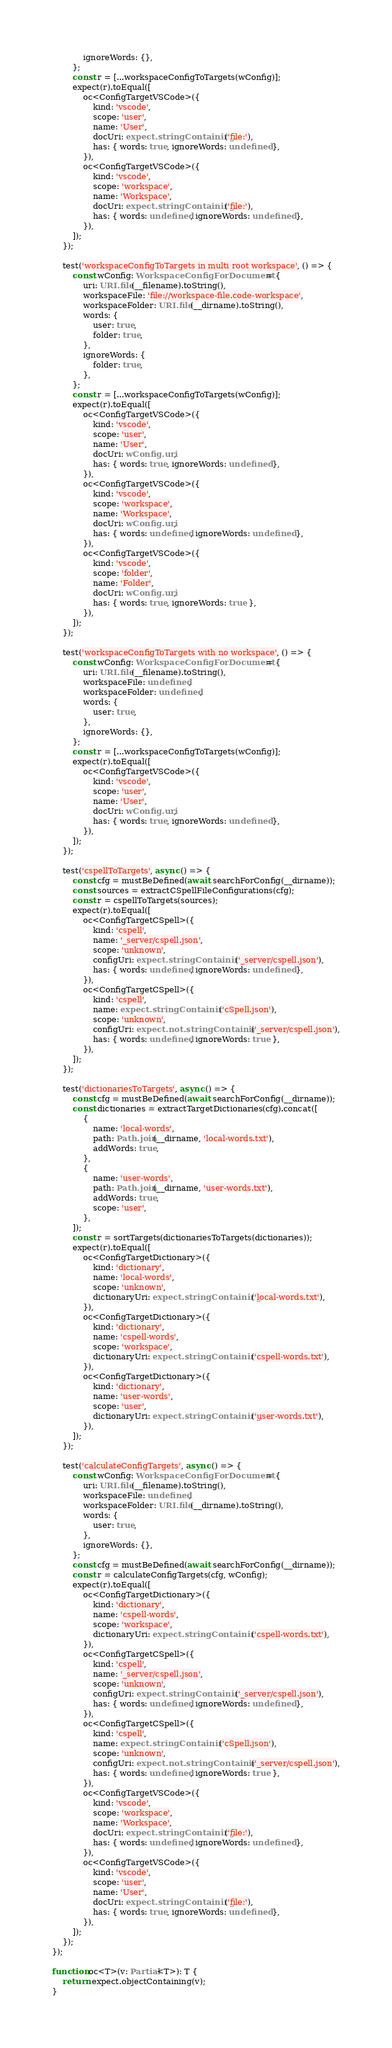Convert code to text. <code><loc_0><loc_0><loc_500><loc_500><_TypeScript_>            ignoreWords: {},
        };
        const r = [...workspaceConfigToTargets(wConfig)];
        expect(r).toEqual([
            oc<ConfigTargetVSCode>({
                kind: 'vscode',
                scope: 'user',
                name: 'User',
                docUri: expect.stringContaining('file:'),
                has: { words: true, ignoreWords: undefined },
            }),
            oc<ConfigTargetVSCode>({
                kind: 'vscode',
                scope: 'workspace',
                name: 'Workspace',
                docUri: expect.stringContaining('file:'),
                has: { words: undefined, ignoreWords: undefined },
            }),
        ]);
    });

    test('workspaceConfigToTargets in multi root workspace', () => {
        const wConfig: WorkspaceConfigForDocument = {
            uri: URI.file(__filename).toString(),
            workspaceFile: 'file://workspace-file.code-workspace',
            workspaceFolder: URI.file(__dirname).toString(),
            words: {
                user: true,
                folder: true,
            },
            ignoreWords: {
                folder: true,
            },
        };
        const r = [...workspaceConfigToTargets(wConfig)];
        expect(r).toEqual([
            oc<ConfigTargetVSCode>({
                kind: 'vscode',
                scope: 'user',
                name: 'User',
                docUri: wConfig.uri,
                has: { words: true, ignoreWords: undefined },
            }),
            oc<ConfigTargetVSCode>({
                kind: 'vscode',
                scope: 'workspace',
                name: 'Workspace',
                docUri: wConfig.uri,
                has: { words: undefined, ignoreWords: undefined },
            }),
            oc<ConfigTargetVSCode>({
                kind: 'vscode',
                scope: 'folder',
                name: 'Folder',
                docUri: wConfig.uri,
                has: { words: true, ignoreWords: true },
            }),
        ]);
    });

    test('workspaceConfigToTargets with no workspace', () => {
        const wConfig: WorkspaceConfigForDocument = {
            uri: URI.file(__filename).toString(),
            workspaceFile: undefined,
            workspaceFolder: undefined,
            words: {
                user: true,
            },
            ignoreWords: {},
        };
        const r = [...workspaceConfigToTargets(wConfig)];
        expect(r).toEqual([
            oc<ConfigTargetVSCode>({
                kind: 'vscode',
                scope: 'user',
                name: 'User',
                docUri: wConfig.uri,
                has: { words: true, ignoreWords: undefined },
            }),
        ]);
    });

    test('cspellToTargets', async () => {
        const cfg = mustBeDefined(await searchForConfig(__dirname));
        const sources = extractCSpellFileConfigurations(cfg);
        const r = cspellToTargets(sources);
        expect(r).toEqual([
            oc<ConfigTargetCSpell>({
                kind: 'cspell',
                name: '_server/cspell.json',
                scope: 'unknown',
                configUri: expect.stringContaining('_server/cspell.json'),
                has: { words: undefined, ignoreWords: undefined },
            }),
            oc<ConfigTargetCSpell>({
                kind: 'cspell',
                name: expect.stringContaining('cSpell.json'),
                scope: 'unknown',
                configUri: expect.not.stringContaining('_server/cspell.json'),
                has: { words: undefined, ignoreWords: true },
            }),
        ]);
    });

    test('dictionariesToTargets', async () => {
        const cfg = mustBeDefined(await searchForConfig(__dirname));
        const dictionaries = extractTargetDictionaries(cfg).concat([
            {
                name: 'local-words',
                path: Path.join(__dirname, 'local-words.txt'),
                addWords: true,
            },
            {
                name: 'user-words',
                path: Path.join(__dirname, 'user-words.txt'),
                addWords: true,
                scope: 'user',
            },
        ]);
        const r = sortTargets(dictionariesToTargets(dictionaries));
        expect(r).toEqual([
            oc<ConfigTargetDictionary>({
                kind: 'dictionary',
                name: 'local-words',
                scope: 'unknown',
                dictionaryUri: expect.stringContaining('local-words.txt'),
            }),
            oc<ConfigTargetDictionary>({
                kind: 'dictionary',
                name: 'cspell-words',
                scope: 'workspace',
                dictionaryUri: expect.stringContaining('cspell-words.txt'),
            }),
            oc<ConfigTargetDictionary>({
                kind: 'dictionary',
                name: 'user-words',
                scope: 'user',
                dictionaryUri: expect.stringContaining('user-words.txt'),
            }),
        ]);
    });

    test('calculateConfigTargets', async () => {
        const wConfig: WorkspaceConfigForDocument = {
            uri: URI.file(__filename).toString(),
            workspaceFile: undefined,
            workspaceFolder: URI.file(__dirname).toString(),
            words: {
                user: true,
            },
            ignoreWords: {},
        };
        const cfg = mustBeDefined(await searchForConfig(__dirname));
        const r = calculateConfigTargets(cfg, wConfig);
        expect(r).toEqual([
            oc<ConfigTargetDictionary>({
                kind: 'dictionary',
                name: 'cspell-words',
                scope: 'workspace',
                dictionaryUri: expect.stringContaining('cspell-words.txt'),
            }),
            oc<ConfigTargetCSpell>({
                kind: 'cspell',
                name: '_server/cspell.json',
                scope: 'unknown',
                configUri: expect.stringContaining('_server/cspell.json'),
                has: { words: undefined, ignoreWords: undefined },
            }),
            oc<ConfigTargetCSpell>({
                kind: 'cspell',
                name: expect.stringContaining('cSpell.json'),
                scope: 'unknown',
                configUri: expect.not.stringContaining('_server/cspell.json'),
                has: { words: undefined, ignoreWords: true },
            }),
            oc<ConfigTargetVSCode>({
                kind: 'vscode',
                scope: 'workspace',
                name: 'Workspace',
                docUri: expect.stringContaining('file:'),
                has: { words: undefined, ignoreWords: undefined },
            }),
            oc<ConfigTargetVSCode>({
                kind: 'vscode',
                scope: 'user',
                name: 'User',
                docUri: expect.stringContaining('file:'),
                has: { words: true, ignoreWords: undefined },
            }),
        ]);
    });
});

function oc<T>(v: Partial<T>): T {
    return expect.objectContaining(v);
}
</code> 